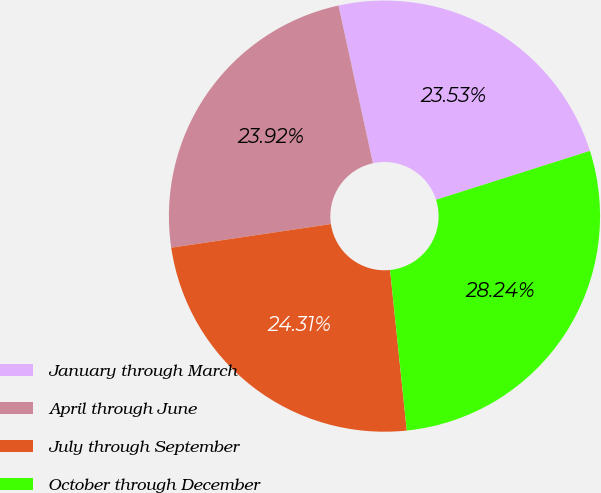Convert chart. <chart><loc_0><loc_0><loc_500><loc_500><pie_chart><fcel>January through March<fcel>April through June<fcel>July through September<fcel>October through December<nl><fcel>23.53%<fcel>23.92%<fcel>24.31%<fcel>28.24%<nl></chart> 